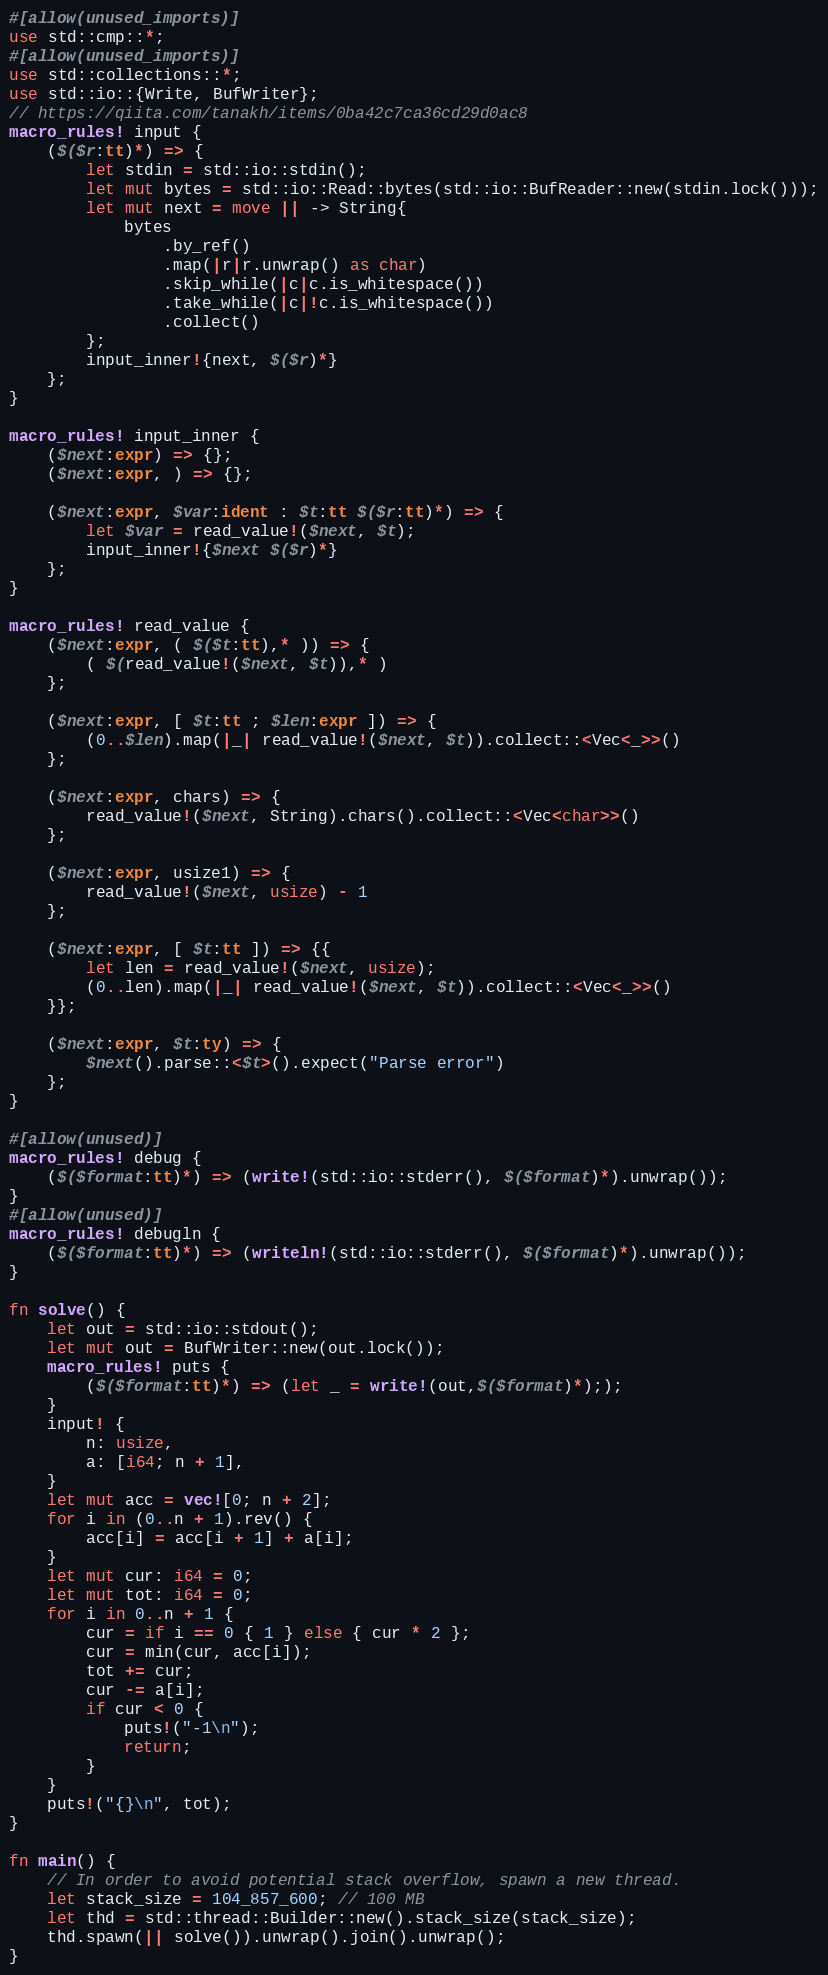<code> <loc_0><loc_0><loc_500><loc_500><_Rust_>#[allow(unused_imports)]
use std::cmp::*;
#[allow(unused_imports)]
use std::collections::*;
use std::io::{Write, BufWriter};
// https://qiita.com/tanakh/items/0ba42c7ca36cd29d0ac8
macro_rules! input {
    ($($r:tt)*) => {
        let stdin = std::io::stdin();
        let mut bytes = std::io::Read::bytes(std::io::BufReader::new(stdin.lock()));
        let mut next = move || -> String{
            bytes
                .by_ref()
                .map(|r|r.unwrap() as char)
                .skip_while(|c|c.is_whitespace())
                .take_while(|c|!c.is_whitespace())
                .collect()
        };
        input_inner!{next, $($r)*}
    };
}

macro_rules! input_inner {
    ($next:expr) => {};
    ($next:expr, ) => {};

    ($next:expr, $var:ident : $t:tt $($r:tt)*) => {
        let $var = read_value!($next, $t);
        input_inner!{$next $($r)*}
    };
}

macro_rules! read_value {
    ($next:expr, ( $($t:tt),* )) => {
        ( $(read_value!($next, $t)),* )
    };

    ($next:expr, [ $t:tt ; $len:expr ]) => {
        (0..$len).map(|_| read_value!($next, $t)).collect::<Vec<_>>()
    };

    ($next:expr, chars) => {
        read_value!($next, String).chars().collect::<Vec<char>>()
    };

    ($next:expr, usize1) => {
        read_value!($next, usize) - 1
    };

    ($next:expr, [ $t:tt ]) => {{
        let len = read_value!($next, usize);
        (0..len).map(|_| read_value!($next, $t)).collect::<Vec<_>>()
    }};

    ($next:expr, $t:ty) => {
        $next().parse::<$t>().expect("Parse error")
    };
}

#[allow(unused)]
macro_rules! debug {
    ($($format:tt)*) => (write!(std::io::stderr(), $($format)*).unwrap());
}
#[allow(unused)]
macro_rules! debugln {
    ($($format:tt)*) => (writeln!(std::io::stderr(), $($format)*).unwrap());
}

fn solve() {
    let out = std::io::stdout();
    let mut out = BufWriter::new(out.lock());
    macro_rules! puts {
        ($($format:tt)*) => (let _ = write!(out,$($format)*););
    }
    input! {
        n: usize,
        a: [i64; n + 1],
    }
    let mut acc = vec![0; n + 2];
    for i in (0..n + 1).rev() {
        acc[i] = acc[i + 1] + a[i];
    }
    let mut cur: i64 = 0;
    let mut tot: i64 = 0;
    for i in 0..n + 1 {
        cur = if i == 0 { 1 } else { cur * 2 };
        cur = min(cur, acc[i]);
        tot += cur;
        cur -= a[i];
        if cur < 0 {
            puts!("-1\n");
            return;
        }
    }
    puts!("{}\n", tot);
}

fn main() {
    // In order to avoid potential stack overflow, spawn a new thread.
    let stack_size = 104_857_600; // 100 MB
    let thd = std::thread::Builder::new().stack_size(stack_size);
    thd.spawn(|| solve()).unwrap().join().unwrap();
}
</code> 